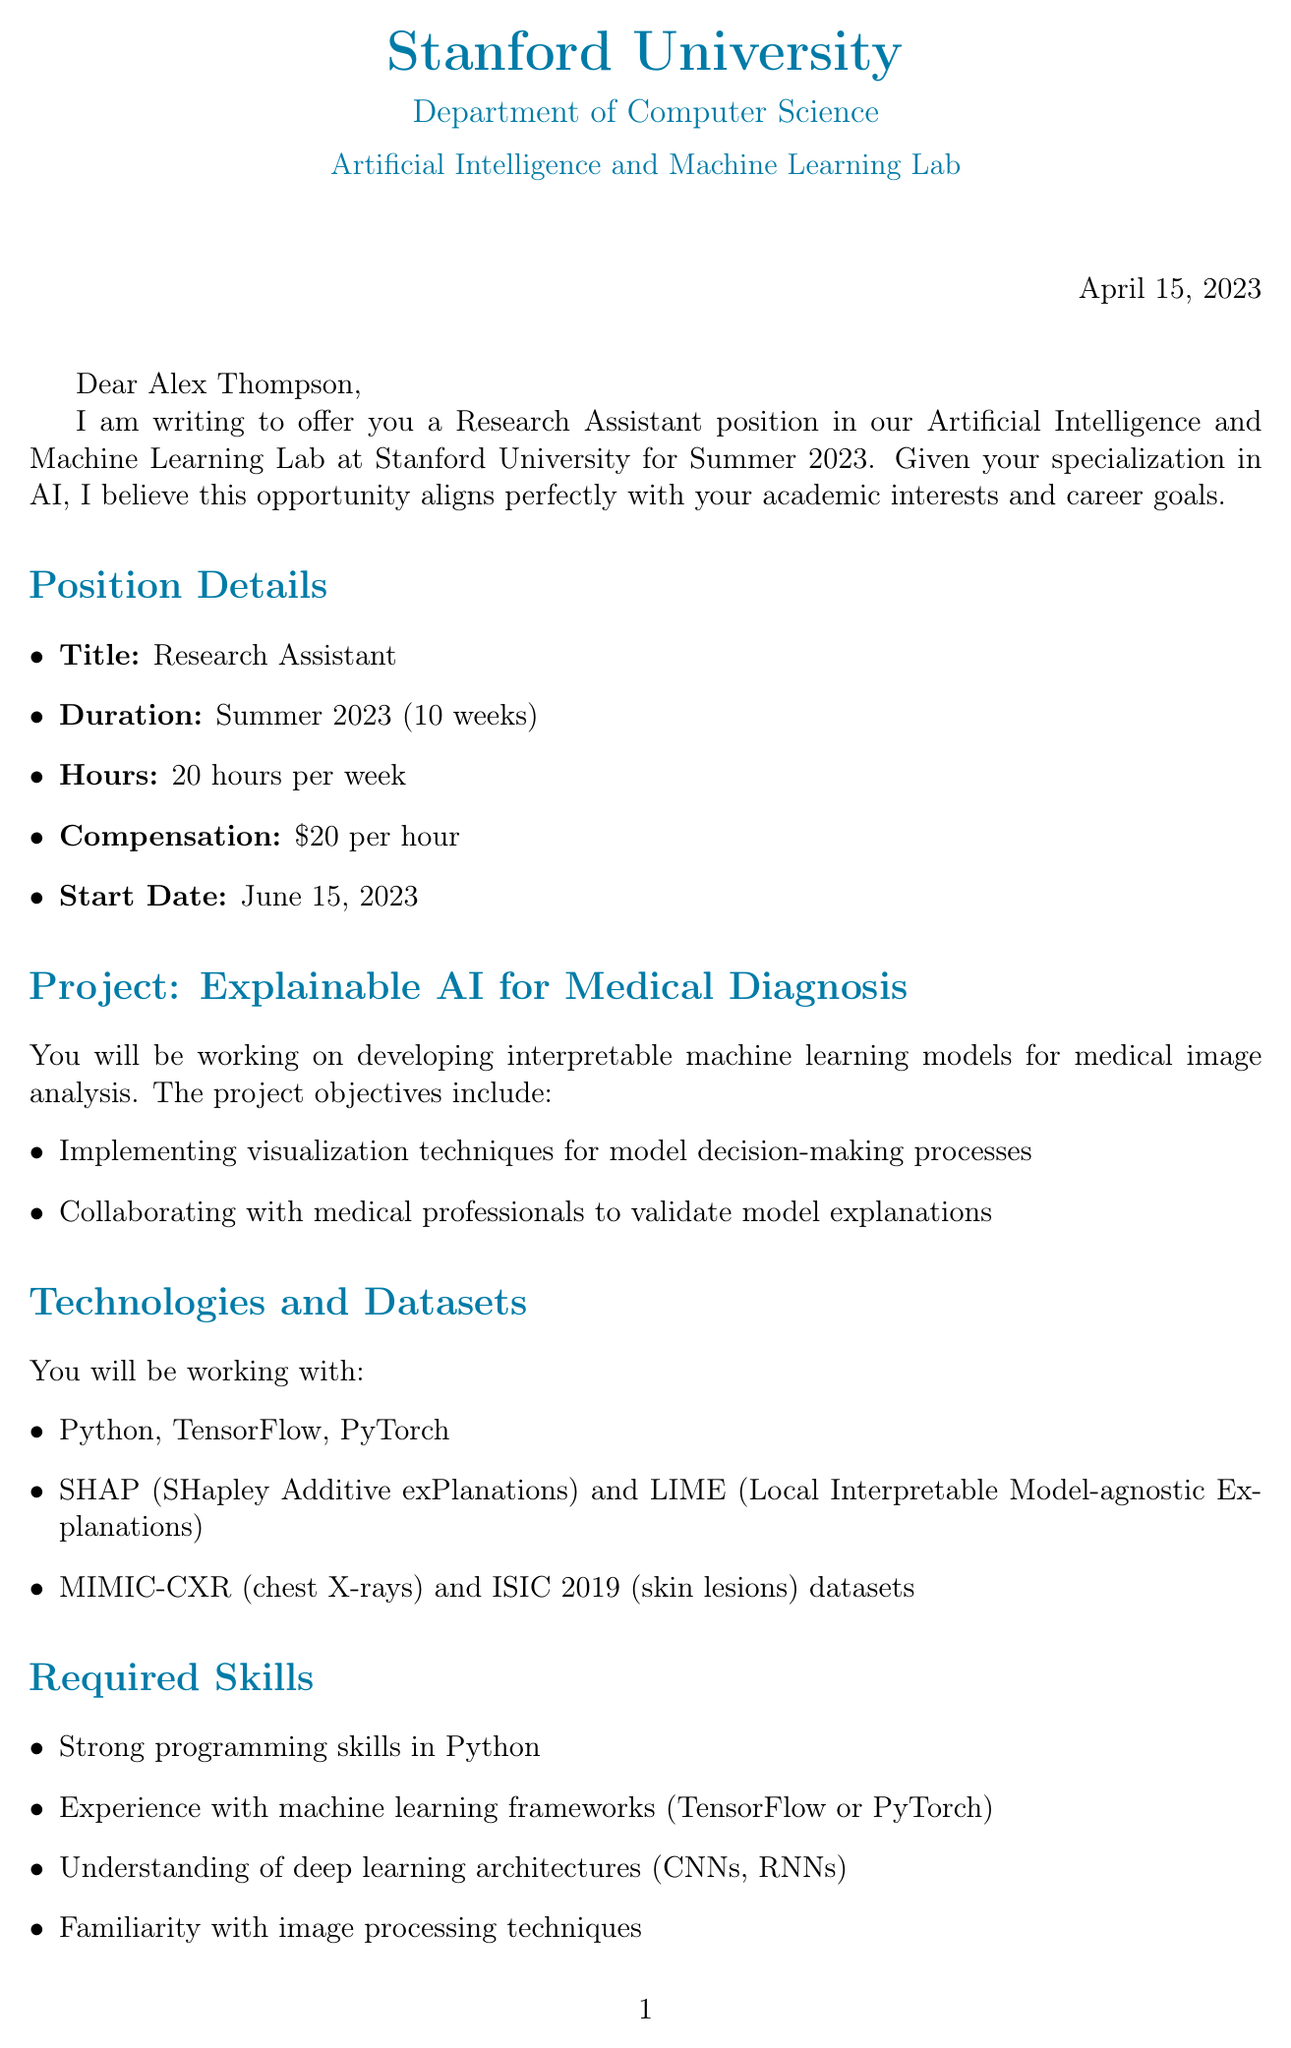What is the name of the professor? The document specifies the professor's name as Dr. Sarah Chen.
Answer: Dr. Sarah Chen What is the position title? The letter states that the position offered is a Research Assistant.
Answer: Research Assistant What is the compensation rate for the position? The compensation mentioned for the position is twenty dollars per hour.
Answer: twenty dollars per hour When does the position start? The document indicates that the start date for the position is June fifteenth, twenty twenty-three.
Answer: June fifteenth, twenty twenty-three What is one of the main project objectives? The document lists various objectives, including developing interpretable machine learning models for medical image analysis.
Answer: Develop interpretable machine learning models for medical image analysis Which programming language is required? The required programming language mentioned in the letter is Python.
Answer: Python What is the deadline for applications? The application deadline presented in the document is April thirtieth, twenty twenty-three.
Answer: April thirtieth, twenty twenty-three What is one of the learning opportunities offered? The letter mentions gaining hands-on experience in cutting-edge AI research as a learning opportunity.
Answer: Gain hands-on experience in cutting-edge AI research What is the method of document submission? The document specifies that applications should be sent via email.
Answer: Email 